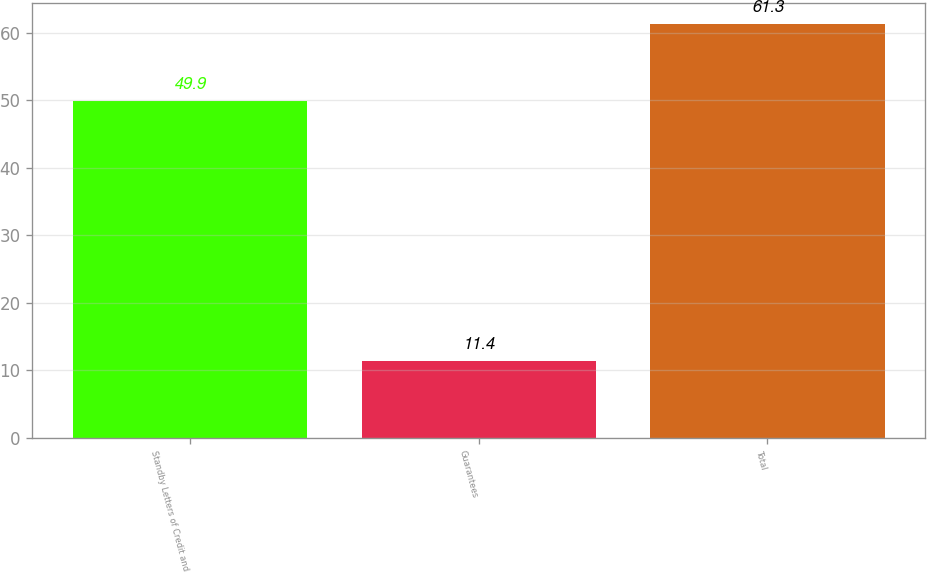<chart> <loc_0><loc_0><loc_500><loc_500><bar_chart><fcel>Standby Letters of Credit and<fcel>Guarantees<fcel>Total<nl><fcel>49.9<fcel>11.4<fcel>61.3<nl></chart> 